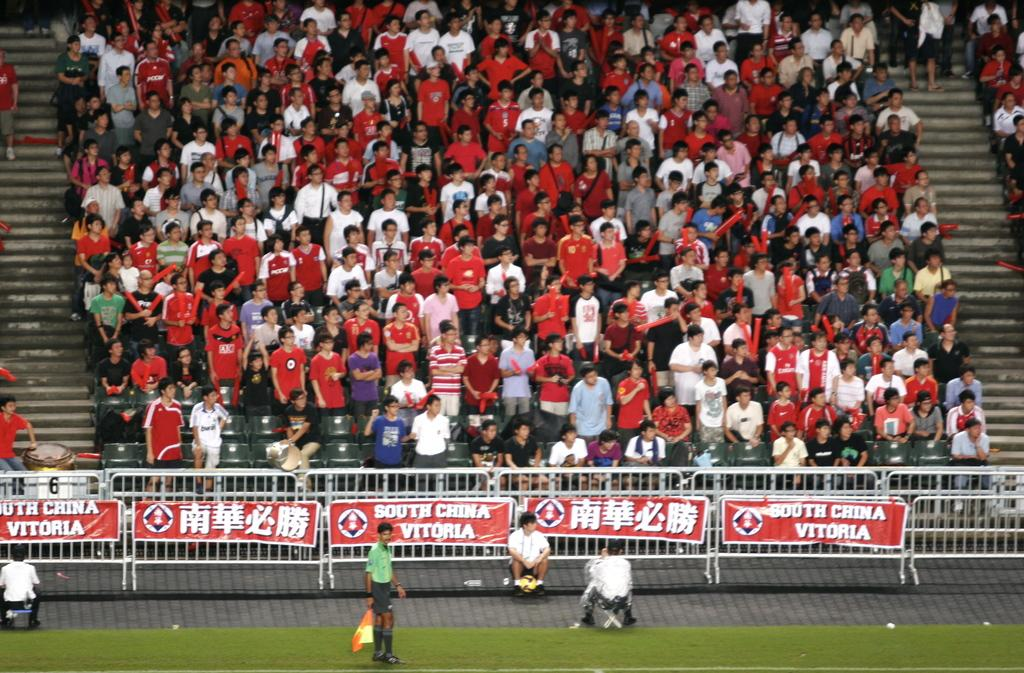<image>
Give a short and clear explanation of the subsequent image. Fans watching a soccer game in the country South China. 